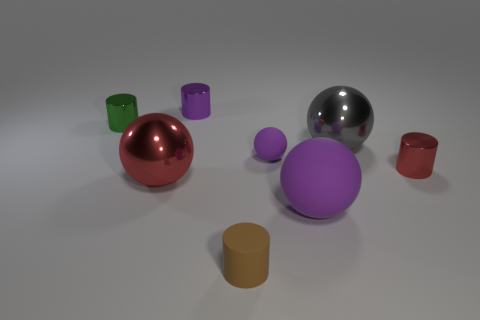Add 2 matte cylinders. How many objects exist? 10 Add 7 gray matte objects. How many gray matte objects exist? 7 Subtract 1 green cylinders. How many objects are left? 7 Subtract all shiny cylinders. Subtract all purple rubber spheres. How many objects are left? 3 Add 4 big objects. How many big objects are left? 7 